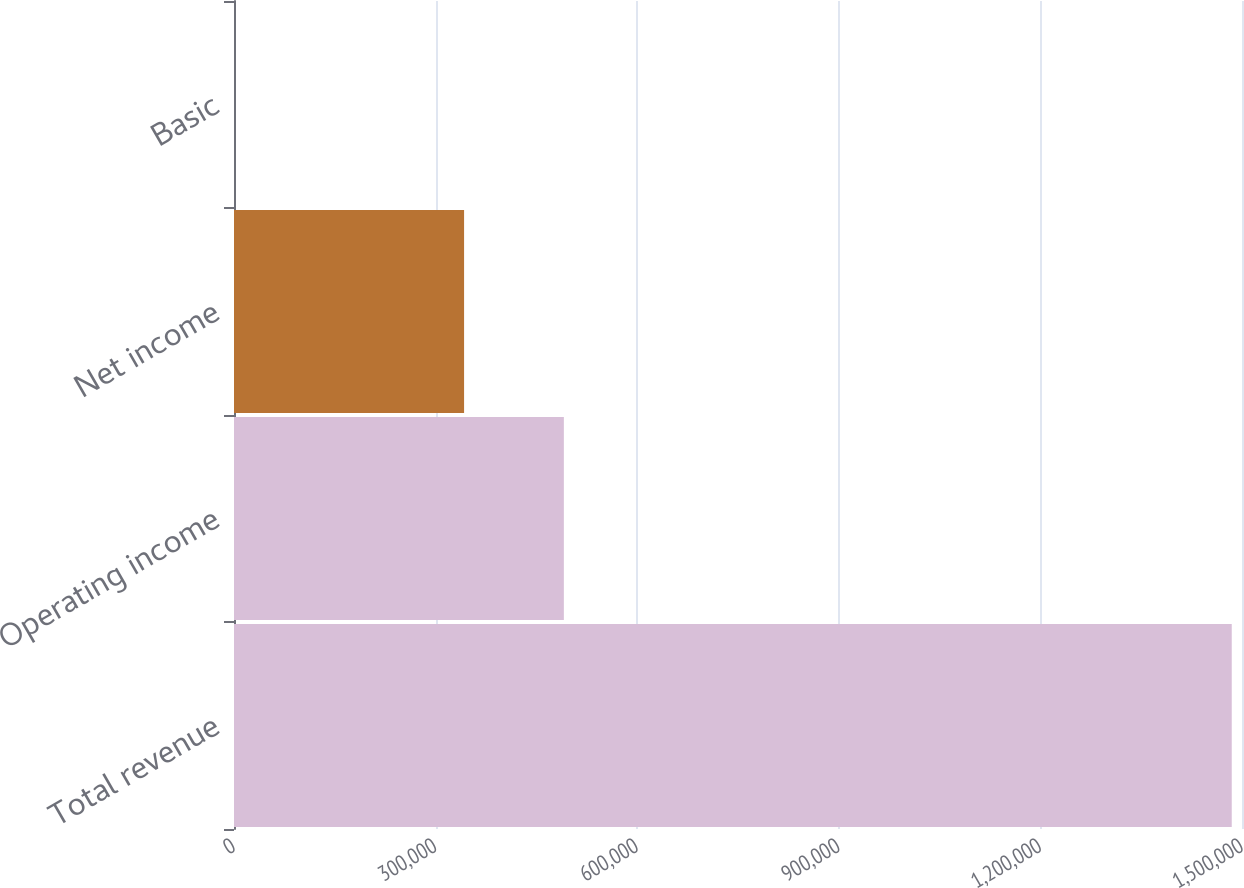Convert chart to OTSL. <chart><loc_0><loc_0><loc_500><loc_500><bar_chart><fcel>Total revenue<fcel>Operating income<fcel>Net income<fcel>Basic<nl><fcel>1.48474e+06<fcel>490851<fcel>342378<fcel>1.51<nl></chart> 